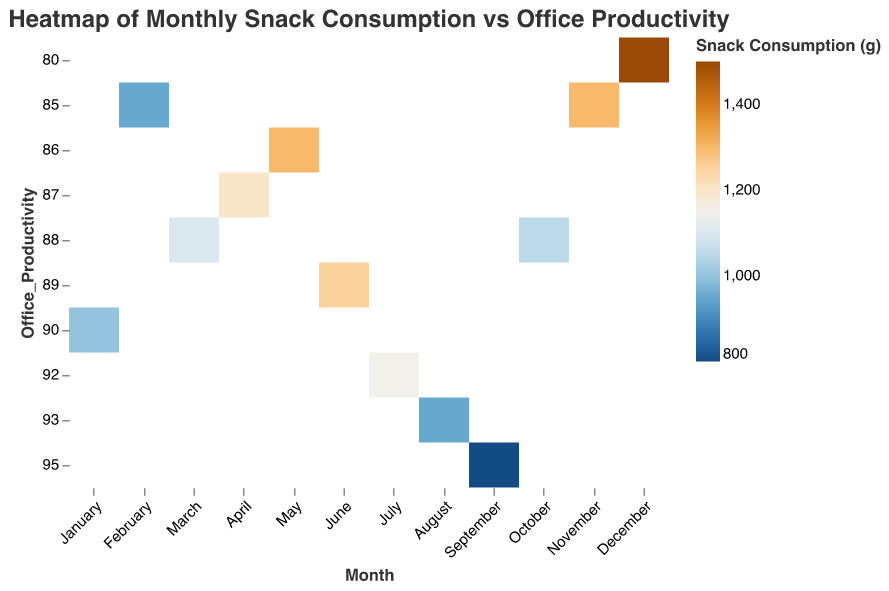What's the title of the heatmap? The title of the heatmap can be found at the top of the figure. It reads "Heatmap of Monthly Snack Consumption vs Office Productivity".
Answer: Heatmap of Monthly Snack Consumption vs Office Productivity What is the range of snack consumption observed in this heatmap? By looking at the color legend and the corresponding data points, the range of snack consumption (in grams) varies from 800 grams to 1500 grams.
Answer: 800 to 1500 grams In which month is the snack consumption highest, and what is the office productivity level at that time? The highest snack consumption is observed in December where the consumption is 1500 grams. The office productivity level during December is 80.
Answer: December, 80 Which month has the highest office productivity and what is the snack consumption in that month? The highest office productivity is observed in September with a productivity level of 95. The snack consumption in September is 800 grams.
Answer: September, 800 grams Compare the snack consumption in January and November. Which month had higher snack consumption and by how much? In January, the snack consumption is 1000 grams and in November, it is 1300 grams. Therefore, November had higher snack consumption by 300 grams.
Answer: November, 300 grams What relationship can you observe between snack consumption and office productivity from the heatmap? Generally, it can be observed that higher snack consumption tends to be associated with lower office productivity levels, and vice versa. This can be seen as snack consumption decreases in months like September and August, productivity levels increase.
Answer: Higher snack consumption generally correlates with lower productivity How many months have a snack consumption greater than 1200 grams? By examining the data values in the heatmap, the months with snack consumption greater than 1200 grams are May, November, and December. That makes a total of three months.
Answer: Three months Identify the month with the lowest snack consumption and specify its productivity level. The lowest snack consumption is observed in September with a consumption of 800 grams. The productivity level for September is 95.
Answer: September, 95 In which months does the snack consumption fall below 1000 grams, and what are their corresponding productivity levels? The months with snack consumption below 1000 grams are February, August, and September. The productivity levels for these months are 85, 93, and 95 respectively.
Answer: February (85), August (93), September (95) By how much did the snack consumption in June differ from that in July, and what were the productivity levels for these months? In June, snack consumption was 1250 grams and in July, it was 1150 grams. The difference is 100 grams. The productivity levels were 89 in June and 92 in July.
Answer: 100 grams, June (89), July (92) 